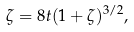Convert formula to latex. <formula><loc_0><loc_0><loc_500><loc_500>\zeta = 8 t ( 1 + \zeta ) ^ { 3 / 2 } ,</formula> 